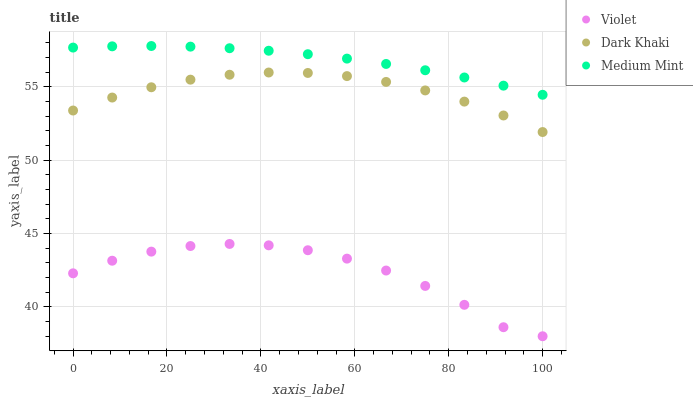Does Violet have the minimum area under the curve?
Answer yes or no. Yes. Does Medium Mint have the maximum area under the curve?
Answer yes or no. Yes. Does Medium Mint have the minimum area under the curve?
Answer yes or no. No. Does Violet have the maximum area under the curve?
Answer yes or no. No. Is Medium Mint the smoothest?
Answer yes or no. Yes. Is Violet the roughest?
Answer yes or no. Yes. Is Violet the smoothest?
Answer yes or no. No. Is Medium Mint the roughest?
Answer yes or no. No. Does Violet have the lowest value?
Answer yes or no. Yes. Does Medium Mint have the lowest value?
Answer yes or no. No. Does Medium Mint have the highest value?
Answer yes or no. Yes. Does Violet have the highest value?
Answer yes or no. No. Is Violet less than Medium Mint?
Answer yes or no. Yes. Is Medium Mint greater than Violet?
Answer yes or no. Yes. Does Violet intersect Medium Mint?
Answer yes or no. No. 